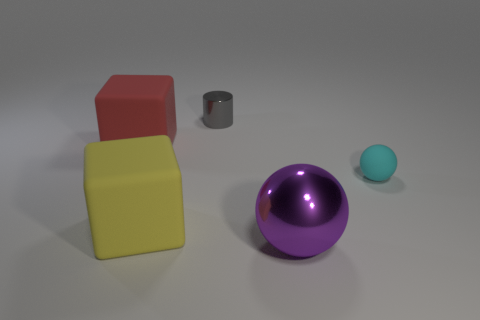Add 1 tiny cylinders. How many objects exist? 6 Subtract all spheres. How many objects are left? 3 Add 1 yellow matte cubes. How many yellow matte cubes are left? 2 Add 1 purple metal balls. How many purple metal balls exist? 2 Subtract 0 green cubes. How many objects are left? 5 Subtract all small cylinders. Subtract all tiny metal things. How many objects are left? 3 